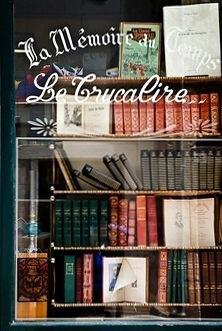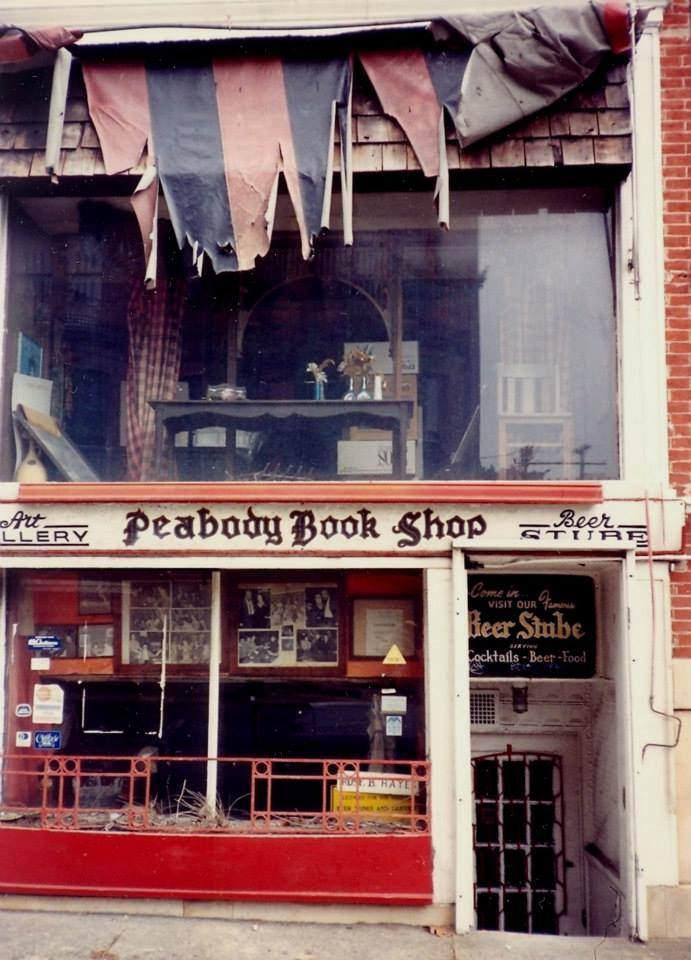The first image is the image on the left, the second image is the image on the right. Examine the images to the left and right. Is the description "In at least one image there is a brick store with at least three window and a black awning." accurate? Answer yes or no. No. The first image is the image on the left, the second image is the image on the right. Examine the images to the left and right. Is the description "The bookstores are all brightly lit up on the inside." accurate? Answer yes or no. No. 